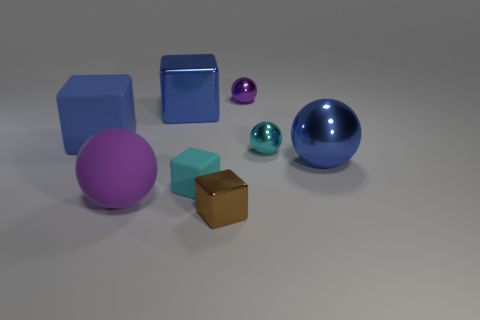Can you tell me how many objects are in the image? Sure, there are six objects in the image. This includes a large blue rubber sphere, a purple matte cube, a brown matte cube, and three smaller spheres—two are cyan, and one is pink. 